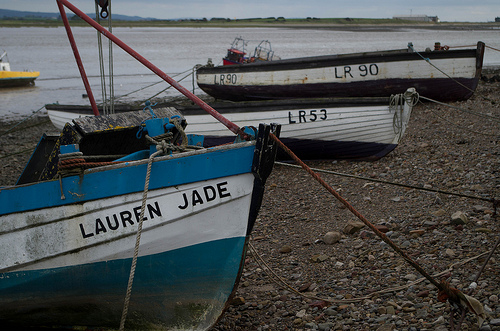How many LR's are visible? 3 